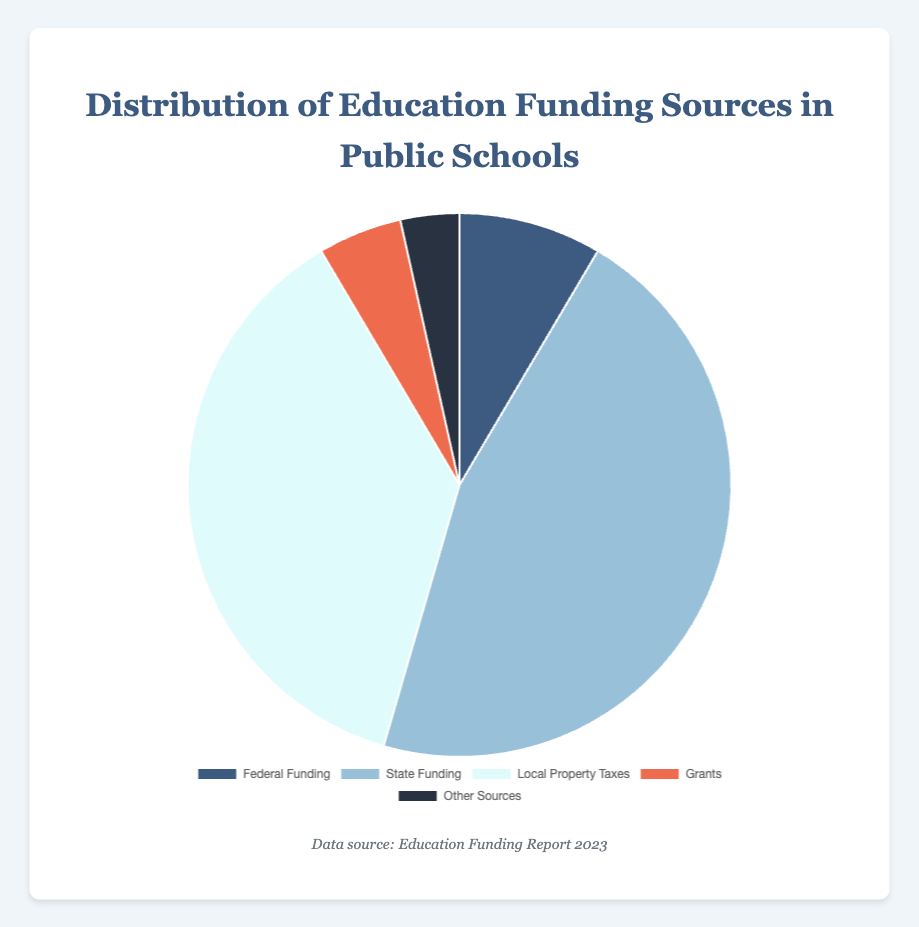What is the largest single source of education funding according to the pie chart? Based on the data provided, the largest percentage belongs to State Funding, which accounts for 46.0% of the total education funding.
Answer: State Funding How much more is the combined percentage of State Funding and Local Property Taxes compared to Federal Funding? First, sum the percentages of State Funding and Local Property Taxes (46.0 + 37.0 = 83.0). Then, subtract the percentage of Federal Funding (83.0 - 8.5 = 74.5).
Answer: 74.5% What portion of the education funding comes from sources other than Federal Funding, State Funding, and Local Property Taxes? Sum the percentages of Grants and Other Sources (5.0 + 3.5 = 8.5).
Answer: 8.5% Which funding source contributes the least to education funding according to the chart? The source with the smallest percentage is Other Sources, which contributes 3.5%.
Answer: Other Sources What is the visual color associated with Local Property Taxes in the pie chart? The color corresponding to Local Property Taxes is identified visually in the pie chart. It is the lightest shade among the colors, specifically light blue.
Answer: Light blue If Funding Source percentages are converted to degrees in the pie chart, what angle corresponds to State Funding? Calculate the angle by multiplying the percentage by 360 degrees (46.0% * 360 = 165.6 degrees).
Answer: 165.6 degrees What is the difference in funding percentages between State Funding and Local Property Taxes? Subtract the percentage of Local Property Taxes from State Funding (46.0 - 37.0 = 9.0).
Answer: 9.0% How much greater is the percentage of Local Property Taxes compared to Grants? Subtract the percentage of Grants from Local Property Taxes (37.0 - 5.0 = 32.0).
Answer: 32.0% What two categories combined equal exactly the percentage of Federal Funding? Federal Funding is 8.5%, and the categories Grants and Other Sources together sum up to 8.5% (5.0 + 3.5 = 8.5).
Answer: Grants and Other Sources How much is the total contribution of both Federal Funding and Other Sources? Add the percentages of Federal Funding and Other Sources (8.5 + 3.5 = 12.0).
Answer: 12.0% 